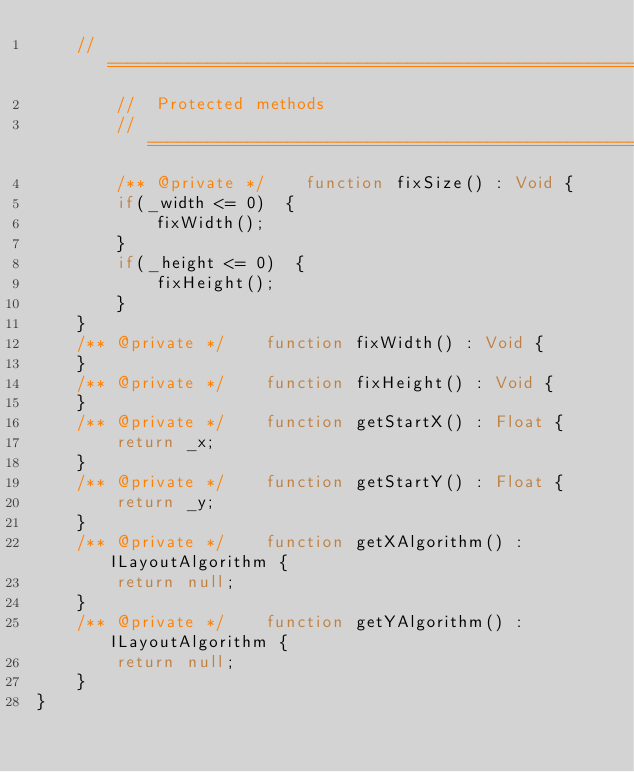<code> <loc_0><loc_0><loc_500><loc_500><_Haxe_>    //======================================================================
        //  Protected methods
        //======================================================================
        /** @private */    function fixSize() : Void {
        if(_width <= 0)  {
            fixWidth();
        }
        if(_height <= 0)  {
            fixHeight();
        }
    }
    /** @private */    function fixWidth() : Void {
    }
    /** @private */    function fixHeight() : Void {
    }
    /** @private */    function getStartX() : Float {
        return _x;
    }
    /** @private */    function getStartY() : Float {
        return _y;
    }
    /** @private */    function getXAlgorithm() : ILayoutAlgorithm {
        return null;
    }
    /** @private */    function getYAlgorithm() : ILayoutAlgorithm {
        return null;
    }
}</code> 